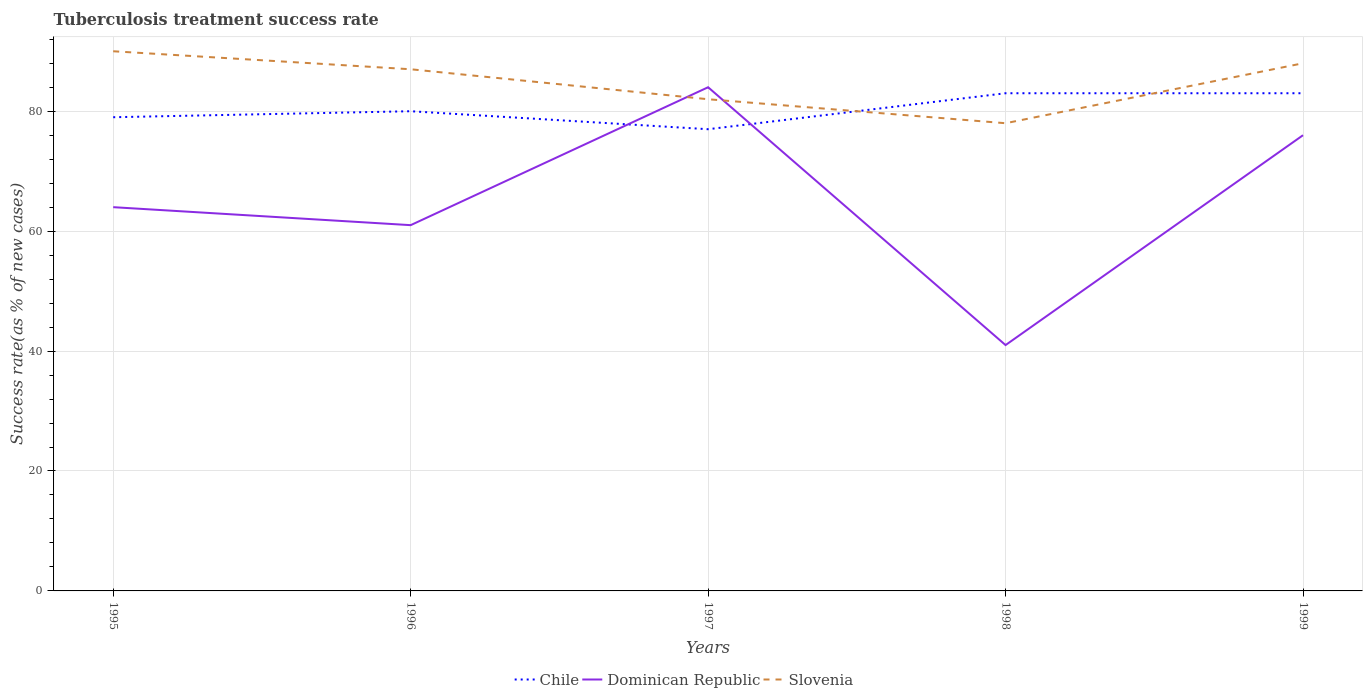Across all years, what is the maximum tuberculosis treatment success rate in Chile?
Ensure brevity in your answer.  77. What is the total tuberculosis treatment success rate in Dominican Republic in the graph?
Provide a succinct answer. 23. What is the difference between the highest and the second highest tuberculosis treatment success rate in Dominican Republic?
Your response must be concise. 43. How many lines are there?
Make the answer very short. 3. What is the difference between two consecutive major ticks on the Y-axis?
Offer a terse response. 20. Does the graph contain grids?
Provide a short and direct response. Yes. Where does the legend appear in the graph?
Offer a terse response. Bottom center. How many legend labels are there?
Your answer should be very brief. 3. How are the legend labels stacked?
Your answer should be compact. Horizontal. What is the title of the graph?
Your answer should be compact. Tuberculosis treatment success rate. What is the label or title of the Y-axis?
Offer a terse response. Success rate(as % of new cases). What is the Success rate(as % of new cases) of Chile in 1995?
Give a very brief answer. 79. What is the Success rate(as % of new cases) in Dominican Republic in 1996?
Your answer should be very brief. 61. What is the Success rate(as % of new cases) of Slovenia in 1996?
Make the answer very short. 87. What is the Success rate(as % of new cases) of Chile in 1997?
Make the answer very short. 77. What is the Success rate(as % of new cases) in Dominican Republic in 1997?
Your response must be concise. 84. What is the Success rate(as % of new cases) of Slovenia in 1997?
Ensure brevity in your answer.  82. What is the Success rate(as % of new cases) of Chile in 1998?
Provide a short and direct response. 83. What is the Success rate(as % of new cases) in Dominican Republic in 1998?
Your answer should be compact. 41. What is the Success rate(as % of new cases) in Chile in 1999?
Ensure brevity in your answer.  83. What is the Success rate(as % of new cases) in Dominican Republic in 1999?
Ensure brevity in your answer.  76. What is the Success rate(as % of new cases) of Slovenia in 1999?
Your answer should be compact. 88. Across all years, what is the maximum Success rate(as % of new cases) in Chile?
Offer a terse response. 83. Across all years, what is the maximum Success rate(as % of new cases) of Slovenia?
Offer a very short reply. 90. What is the total Success rate(as % of new cases) of Chile in the graph?
Your answer should be compact. 402. What is the total Success rate(as % of new cases) in Dominican Republic in the graph?
Offer a very short reply. 326. What is the total Success rate(as % of new cases) in Slovenia in the graph?
Offer a very short reply. 425. What is the difference between the Success rate(as % of new cases) of Slovenia in 1995 and that in 1996?
Keep it short and to the point. 3. What is the difference between the Success rate(as % of new cases) in Chile in 1995 and that in 1997?
Offer a very short reply. 2. What is the difference between the Success rate(as % of new cases) of Dominican Republic in 1995 and that in 1997?
Keep it short and to the point. -20. What is the difference between the Success rate(as % of new cases) of Slovenia in 1995 and that in 1997?
Give a very brief answer. 8. What is the difference between the Success rate(as % of new cases) of Chile in 1995 and that in 1998?
Offer a very short reply. -4. What is the difference between the Success rate(as % of new cases) of Dominican Republic in 1995 and that in 1998?
Give a very brief answer. 23. What is the difference between the Success rate(as % of new cases) of Chile in 1995 and that in 1999?
Ensure brevity in your answer.  -4. What is the difference between the Success rate(as % of new cases) of Dominican Republic in 1995 and that in 1999?
Your answer should be very brief. -12. What is the difference between the Success rate(as % of new cases) in Dominican Republic in 1996 and that in 1997?
Ensure brevity in your answer.  -23. What is the difference between the Success rate(as % of new cases) of Chile in 1996 and that in 1998?
Provide a short and direct response. -3. What is the difference between the Success rate(as % of new cases) of Dominican Republic in 1996 and that in 1998?
Your response must be concise. 20. What is the difference between the Success rate(as % of new cases) of Slovenia in 1996 and that in 1998?
Provide a succinct answer. 9. What is the difference between the Success rate(as % of new cases) in Chile in 1996 and that in 1999?
Offer a terse response. -3. What is the difference between the Success rate(as % of new cases) in Dominican Republic in 1996 and that in 1999?
Offer a terse response. -15. What is the difference between the Success rate(as % of new cases) in Slovenia in 1997 and that in 1998?
Offer a very short reply. 4. What is the difference between the Success rate(as % of new cases) in Chile in 1997 and that in 1999?
Give a very brief answer. -6. What is the difference between the Success rate(as % of new cases) of Slovenia in 1997 and that in 1999?
Ensure brevity in your answer.  -6. What is the difference between the Success rate(as % of new cases) of Dominican Republic in 1998 and that in 1999?
Provide a succinct answer. -35. What is the difference between the Success rate(as % of new cases) in Chile in 1995 and the Success rate(as % of new cases) in Slovenia in 1996?
Offer a terse response. -8. What is the difference between the Success rate(as % of new cases) in Dominican Republic in 1995 and the Success rate(as % of new cases) in Slovenia in 1996?
Ensure brevity in your answer.  -23. What is the difference between the Success rate(as % of new cases) in Chile in 1995 and the Success rate(as % of new cases) in Dominican Republic in 1997?
Your answer should be compact. -5. What is the difference between the Success rate(as % of new cases) of Chile in 1995 and the Success rate(as % of new cases) of Dominican Republic in 1998?
Offer a very short reply. 38. What is the difference between the Success rate(as % of new cases) of Dominican Republic in 1995 and the Success rate(as % of new cases) of Slovenia in 1998?
Provide a short and direct response. -14. What is the difference between the Success rate(as % of new cases) of Chile in 1995 and the Success rate(as % of new cases) of Dominican Republic in 1999?
Provide a short and direct response. 3. What is the difference between the Success rate(as % of new cases) of Chile in 1995 and the Success rate(as % of new cases) of Slovenia in 1999?
Give a very brief answer. -9. What is the difference between the Success rate(as % of new cases) in Dominican Republic in 1996 and the Success rate(as % of new cases) in Slovenia in 1997?
Your answer should be very brief. -21. What is the difference between the Success rate(as % of new cases) of Chile in 1996 and the Success rate(as % of new cases) of Dominican Republic in 1998?
Offer a terse response. 39. What is the difference between the Success rate(as % of new cases) of Chile in 1996 and the Success rate(as % of new cases) of Slovenia in 1998?
Keep it short and to the point. 2. What is the difference between the Success rate(as % of new cases) of Chile in 1996 and the Success rate(as % of new cases) of Dominican Republic in 1999?
Offer a very short reply. 4. What is the difference between the Success rate(as % of new cases) of Chile in 1997 and the Success rate(as % of new cases) of Dominican Republic in 1998?
Make the answer very short. 36. What is the difference between the Success rate(as % of new cases) of Chile in 1998 and the Success rate(as % of new cases) of Dominican Republic in 1999?
Ensure brevity in your answer.  7. What is the difference between the Success rate(as % of new cases) of Dominican Republic in 1998 and the Success rate(as % of new cases) of Slovenia in 1999?
Provide a succinct answer. -47. What is the average Success rate(as % of new cases) in Chile per year?
Offer a very short reply. 80.4. What is the average Success rate(as % of new cases) in Dominican Republic per year?
Offer a terse response. 65.2. What is the average Success rate(as % of new cases) in Slovenia per year?
Give a very brief answer. 85. In the year 1996, what is the difference between the Success rate(as % of new cases) in Chile and Success rate(as % of new cases) in Slovenia?
Offer a terse response. -7. In the year 1997, what is the difference between the Success rate(as % of new cases) of Dominican Republic and Success rate(as % of new cases) of Slovenia?
Give a very brief answer. 2. In the year 1998, what is the difference between the Success rate(as % of new cases) of Dominican Republic and Success rate(as % of new cases) of Slovenia?
Offer a very short reply. -37. In the year 1999, what is the difference between the Success rate(as % of new cases) in Chile and Success rate(as % of new cases) in Dominican Republic?
Your answer should be very brief. 7. In the year 1999, what is the difference between the Success rate(as % of new cases) of Chile and Success rate(as % of new cases) of Slovenia?
Offer a terse response. -5. In the year 1999, what is the difference between the Success rate(as % of new cases) in Dominican Republic and Success rate(as % of new cases) in Slovenia?
Give a very brief answer. -12. What is the ratio of the Success rate(as % of new cases) of Chile in 1995 to that in 1996?
Ensure brevity in your answer.  0.99. What is the ratio of the Success rate(as % of new cases) of Dominican Republic in 1995 to that in 1996?
Your response must be concise. 1.05. What is the ratio of the Success rate(as % of new cases) in Slovenia in 1995 to that in 1996?
Provide a short and direct response. 1.03. What is the ratio of the Success rate(as % of new cases) of Chile in 1995 to that in 1997?
Your response must be concise. 1.03. What is the ratio of the Success rate(as % of new cases) in Dominican Republic in 1995 to that in 1997?
Make the answer very short. 0.76. What is the ratio of the Success rate(as % of new cases) of Slovenia in 1995 to that in 1997?
Make the answer very short. 1.1. What is the ratio of the Success rate(as % of new cases) in Chile in 1995 to that in 1998?
Your answer should be very brief. 0.95. What is the ratio of the Success rate(as % of new cases) of Dominican Republic in 1995 to that in 1998?
Provide a short and direct response. 1.56. What is the ratio of the Success rate(as % of new cases) of Slovenia in 1995 to that in 1998?
Your answer should be very brief. 1.15. What is the ratio of the Success rate(as % of new cases) in Chile in 1995 to that in 1999?
Give a very brief answer. 0.95. What is the ratio of the Success rate(as % of new cases) of Dominican Republic in 1995 to that in 1999?
Your response must be concise. 0.84. What is the ratio of the Success rate(as % of new cases) of Slovenia in 1995 to that in 1999?
Keep it short and to the point. 1.02. What is the ratio of the Success rate(as % of new cases) in Chile in 1996 to that in 1997?
Offer a terse response. 1.04. What is the ratio of the Success rate(as % of new cases) of Dominican Republic in 1996 to that in 1997?
Your answer should be very brief. 0.73. What is the ratio of the Success rate(as % of new cases) in Slovenia in 1996 to that in 1997?
Offer a very short reply. 1.06. What is the ratio of the Success rate(as % of new cases) of Chile in 1996 to that in 1998?
Make the answer very short. 0.96. What is the ratio of the Success rate(as % of new cases) in Dominican Republic in 1996 to that in 1998?
Make the answer very short. 1.49. What is the ratio of the Success rate(as % of new cases) in Slovenia in 1996 to that in 1998?
Your response must be concise. 1.12. What is the ratio of the Success rate(as % of new cases) of Chile in 1996 to that in 1999?
Your answer should be compact. 0.96. What is the ratio of the Success rate(as % of new cases) of Dominican Republic in 1996 to that in 1999?
Your response must be concise. 0.8. What is the ratio of the Success rate(as % of new cases) of Slovenia in 1996 to that in 1999?
Your response must be concise. 0.99. What is the ratio of the Success rate(as % of new cases) of Chile in 1997 to that in 1998?
Provide a succinct answer. 0.93. What is the ratio of the Success rate(as % of new cases) in Dominican Republic in 1997 to that in 1998?
Your answer should be very brief. 2.05. What is the ratio of the Success rate(as % of new cases) in Slovenia in 1997 to that in 1998?
Your response must be concise. 1.05. What is the ratio of the Success rate(as % of new cases) in Chile in 1997 to that in 1999?
Your answer should be very brief. 0.93. What is the ratio of the Success rate(as % of new cases) in Dominican Republic in 1997 to that in 1999?
Ensure brevity in your answer.  1.11. What is the ratio of the Success rate(as % of new cases) of Slovenia in 1997 to that in 1999?
Your answer should be very brief. 0.93. What is the ratio of the Success rate(as % of new cases) in Chile in 1998 to that in 1999?
Offer a terse response. 1. What is the ratio of the Success rate(as % of new cases) in Dominican Republic in 1998 to that in 1999?
Offer a very short reply. 0.54. What is the ratio of the Success rate(as % of new cases) in Slovenia in 1998 to that in 1999?
Keep it short and to the point. 0.89. What is the difference between the highest and the second highest Success rate(as % of new cases) in Slovenia?
Keep it short and to the point. 2. What is the difference between the highest and the lowest Success rate(as % of new cases) in Dominican Republic?
Provide a succinct answer. 43. What is the difference between the highest and the lowest Success rate(as % of new cases) in Slovenia?
Offer a terse response. 12. 